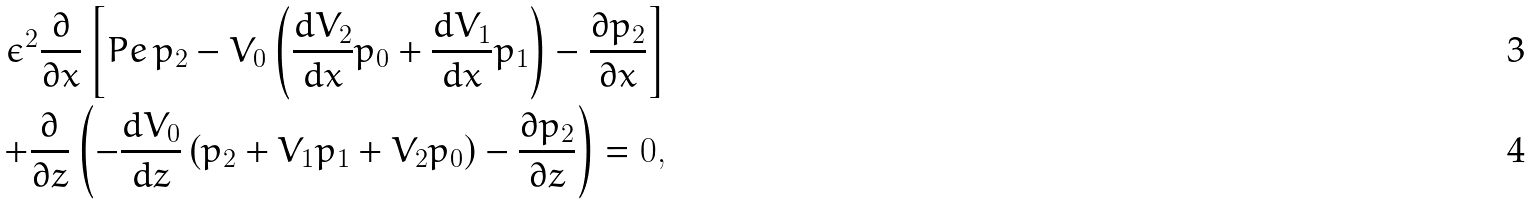Convert formula to latex. <formula><loc_0><loc_0><loc_500><loc_500>\epsilon ^ { 2 } \frac { \partial } { \partial x } \left [ P e \, p _ { 2 } - V _ { 0 } \left ( \frac { d V _ { 2 } } { d x } p _ { 0 } + \frac { d V _ { 1 } } { d x } p _ { 1 } \right ) - \frac { \partial p _ { 2 } } { \partial x } \right ] \\ + \frac { \partial } { \partial z } \left ( - \frac { d V _ { 0 } } { d z } \left ( p _ { 2 } + V _ { 1 } p _ { 1 } + V _ { 2 } p _ { 0 } \right ) - \frac { \partial p _ { 2 } } { \partial z } \right ) = 0 ,</formula> 